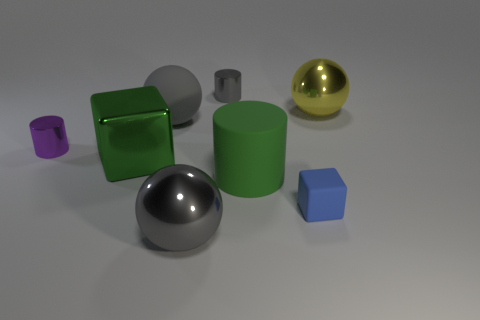Are any cyan rubber balls visible?
Ensure brevity in your answer.  No. What number of rubber cylinders have the same size as the yellow object?
Ensure brevity in your answer.  1. Are there more green matte things left of the blue rubber object than large green metallic blocks in front of the gray shiny sphere?
Your response must be concise. Yes. There is a purple cylinder that is the same size as the gray cylinder; what material is it?
Give a very brief answer. Metal. The large gray rubber thing has what shape?
Offer a terse response. Sphere. What number of green objects are cylinders or blocks?
Provide a succinct answer. 2. What is the size of the other cylinder that is the same material as the gray cylinder?
Your response must be concise. Small. Is the material of the gray ball behind the large green rubber thing the same as the small blue block that is in front of the tiny purple object?
Your answer should be very brief. Yes. How many cylinders are small metal objects or blue things?
Make the answer very short. 2. There is a metallic cylinder that is in front of the metal sphere that is behind the shiny cube; how many small shiny objects are right of it?
Your response must be concise. 1. 